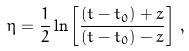<formula> <loc_0><loc_0><loc_500><loc_500>\eta = \frac { 1 } { 2 } \ln \left [ \frac { ( t - t _ { 0 } ) + z } { ( t - t _ { 0 } ) - z } \right ] \, ,</formula> 